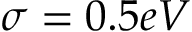Convert formula to latex. <formula><loc_0><loc_0><loc_500><loc_500>\sigma = 0 . 5 e V</formula> 